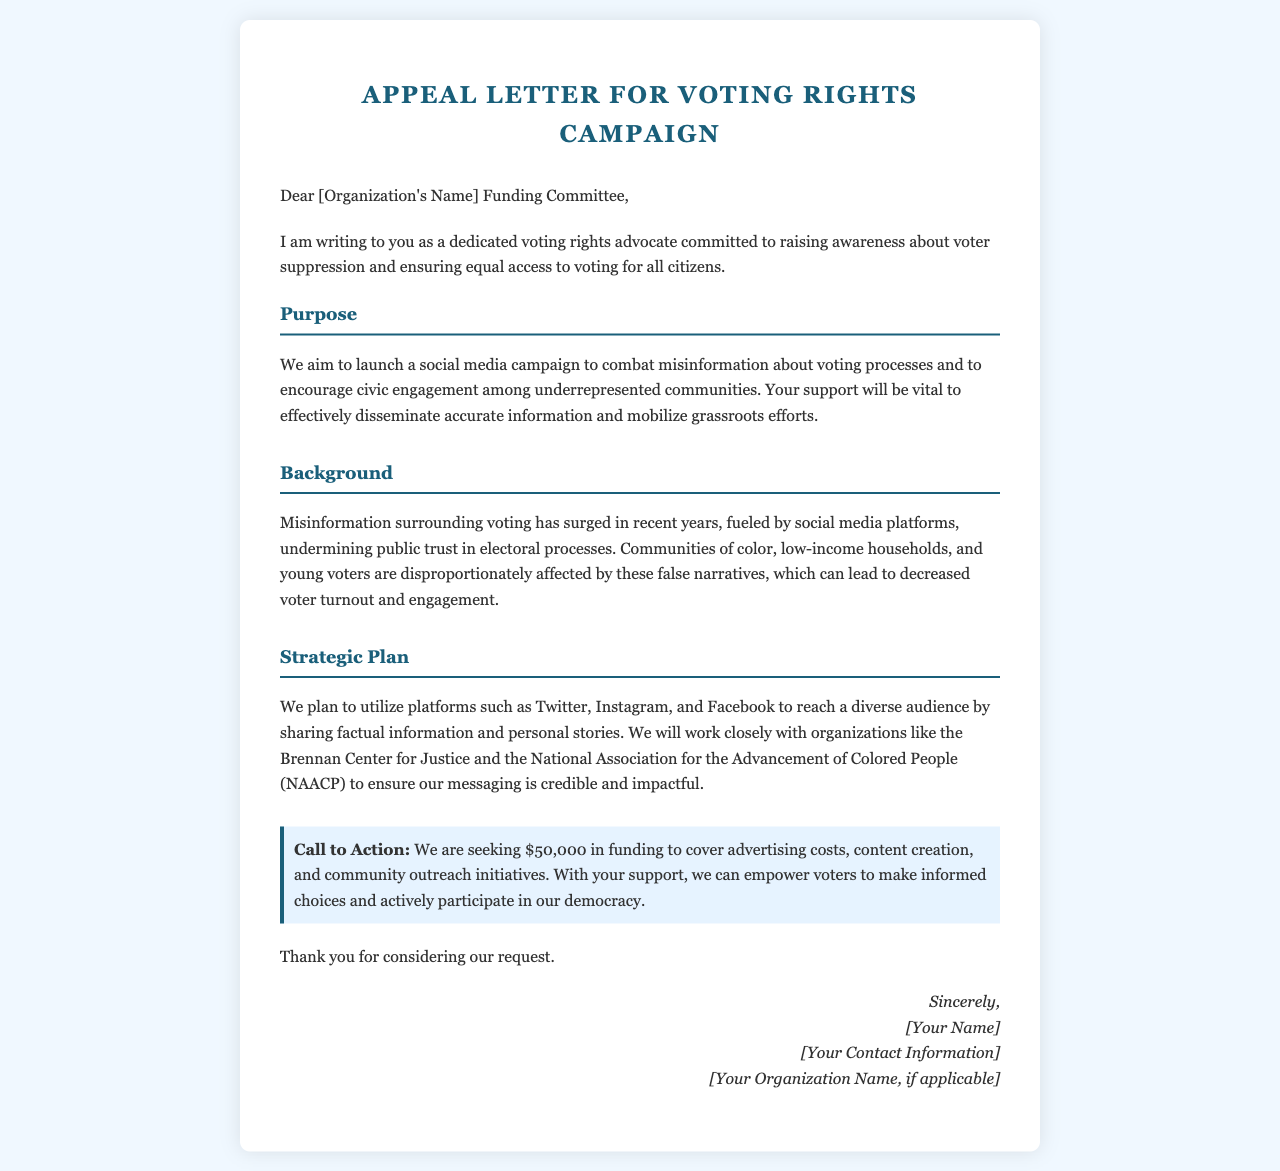What is the main purpose of the proposed campaign? The main purpose of the campaign is to combat misinformation about voting processes and to encourage civic engagement among underrepresented communities.
Answer: To combat misinformation and encourage civic engagement How much funding is being requested? The funding request is explicitly stated in the letter as necessary for the campaign's success.
Answer: $50,000 Which communities are most affected by misinformation according to the letter? The letter highlights specific demographics that have been negatively impacted by misinformation about voting.
Answer: Communities of color, low-income households, and young voters What are the platforms mentioned for the social media campaign? The letter lists specific social media platforms intended for outreach, signifying their importance in the campaign.
Answer: Twitter, Instagram, and Facebook Which organizations will be collaborated with for messaging? The letter identifies two organizations that are important partners in ensuring that the campaign's messaging is credible.
Answer: Brennan Center for Justice and NAACP What is the structure of the letter? The letter follows a specific structure, often used in appeals, which organizes content into designated sections.
Answer: Sections (Purpose, Background, Strategic Plan) What is the call to action in the letter? The letter emphasizes a specific request that indicates immediate action needed from the funding committee.
Answer: Seeking $50,000 in funding Who is the letter addressed to? The intended recipient of the letter is clearly identified at the beginning, indicating a formal request for support.
Answer: [Organization's Name] Funding Committee 